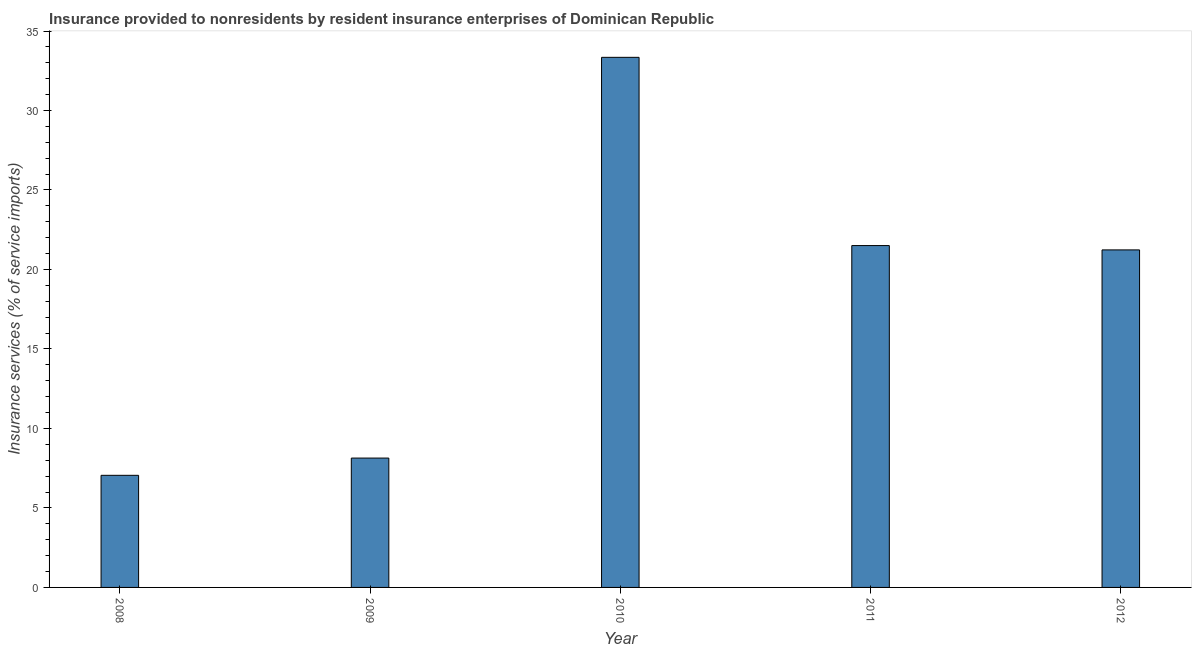Does the graph contain any zero values?
Keep it short and to the point. No. What is the title of the graph?
Offer a terse response. Insurance provided to nonresidents by resident insurance enterprises of Dominican Republic. What is the label or title of the Y-axis?
Ensure brevity in your answer.  Insurance services (% of service imports). What is the insurance and financial services in 2010?
Make the answer very short. 33.35. Across all years, what is the maximum insurance and financial services?
Provide a short and direct response. 33.35. Across all years, what is the minimum insurance and financial services?
Your answer should be compact. 7.05. In which year was the insurance and financial services maximum?
Keep it short and to the point. 2010. In which year was the insurance and financial services minimum?
Keep it short and to the point. 2008. What is the sum of the insurance and financial services?
Provide a succinct answer. 91.27. What is the difference between the insurance and financial services in 2010 and 2012?
Your answer should be compact. 12.11. What is the average insurance and financial services per year?
Offer a very short reply. 18.25. What is the median insurance and financial services?
Make the answer very short. 21.23. Do a majority of the years between 2009 and 2011 (inclusive) have insurance and financial services greater than 6 %?
Your answer should be very brief. Yes. What is the ratio of the insurance and financial services in 2009 to that in 2012?
Provide a succinct answer. 0.38. What is the difference between the highest and the second highest insurance and financial services?
Ensure brevity in your answer.  11.84. What is the difference between the highest and the lowest insurance and financial services?
Provide a short and direct response. 26.29. How many bars are there?
Offer a very short reply. 5. Are all the bars in the graph horizontal?
Provide a succinct answer. No. Are the values on the major ticks of Y-axis written in scientific E-notation?
Provide a succinct answer. No. What is the Insurance services (% of service imports) of 2008?
Your response must be concise. 7.05. What is the Insurance services (% of service imports) of 2009?
Your answer should be compact. 8.14. What is the Insurance services (% of service imports) in 2010?
Give a very brief answer. 33.35. What is the Insurance services (% of service imports) of 2011?
Keep it short and to the point. 21.5. What is the Insurance services (% of service imports) of 2012?
Your response must be concise. 21.23. What is the difference between the Insurance services (% of service imports) in 2008 and 2009?
Provide a short and direct response. -1.08. What is the difference between the Insurance services (% of service imports) in 2008 and 2010?
Provide a succinct answer. -26.29. What is the difference between the Insurance services (% of service imports) in 2008 and 2011?
Keep it short and to the point. -14.45. What is the difference between the Insurance services (% of service imports) in 2008 and 2012?
Ensure brevity in your answer.  -14.18. What is the difference between the Insurance services (% of service imports) in 2009 and 2010?
Make the answer very short. -25.21. What is the difference between the Insurance services (% of service imports) in 2009 and 2011?
Provide a succinct answer. -13.37. What is the difference between the Insurance services (% of service imports) in 2009 and 2012?
Your response must be concise. -13.1. What is the difference between the Insurance services (% of service imports) in 2010 and 2011?
Keep it short and to the point. 11.84. What is the difference between the Insurance services (% of service imports) in 2010 and 2012?
Your response must be concise. 12.11. What is the difference between the Insurance services (% of service imports) in 2011 and 2012?
Ensure brevity in your answer.  0.27. What is the ratio of the Insurance services (% of service imports) in 2008 to that in 2009?
Offer a terse response. 0.87. What is the ratio of the Insurance services (% of service imports) in 2008 to that in 2010?
Make the answer very short. 0.21. What is the ratio of the Insurance services (% of service imports) in 2008 to that in 2011?
Give a very brief answer. 0.33. What is the ratio of the Insurance services (% of service imports) in 2008 to that in 2012?
Your response must be concise. 0.33. What is the ratio of the Insurance services (% of service imports) in 2009 to that in 2010?
Your answer should be compact. 0.24. What is the ratio of the Insurance services (% of service imports) in 2009 to that in 2011?
Your response must be concise. 0.38. What is the ratio of the Insurance services (% of service imports) in 2009 to that in 2012?
Offer a very short reply. 0.38. What is the ratio of the Insurance services (% of service imports) in 2010 to that in 2011?
Give a very brief answer. 1.55. What is the ratio of the Insurance services (% of service imports) in 2010 to that in 2012?
Give a very brief answer. 1.57. 